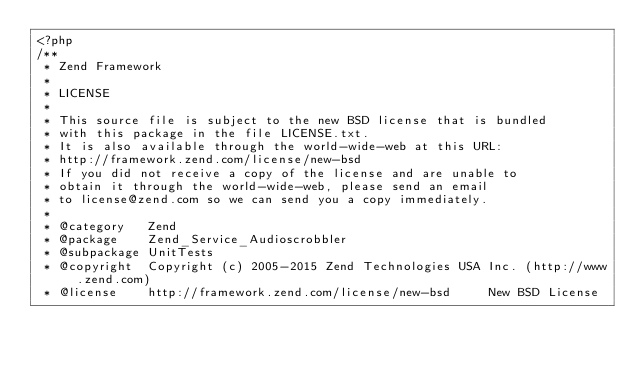Convert code to text. <code><loc_0><loc_0><loc_500><loc_500><_PHP_><?php
/**
 * Zend Framework
 *
 * LICENSE
 *
 * This source file is subject to the new BSD license that is bundled
 * with this package in the file LICENSE.txt.
 * It is also available through the world-wide-web at this URL:
 * http://framework.zend.com/license/new-bsd
 * If you did not receive a copy of the license and are unable to
 * obtain it through the world-wide-web, please send an email
 * to license@zend.com so we can send you a copy immediately.
 *
 * @category   Zend
 * @package    Zend_Service_Audioscrobbler
 * @subpackage UnitTests
 * @copyright  Copyright (c) 2005-2015 Zend Technologies USA Inc. (http://www.zend.com)
 * @license    http://framework.zend.com/license/new-bsd     New BSD License</code> 